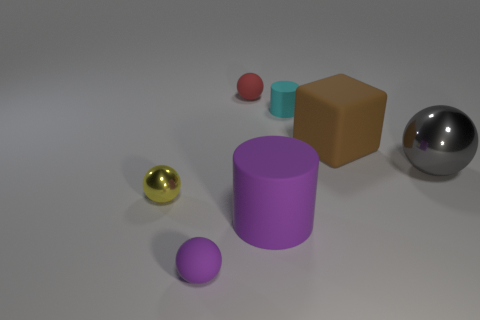There is a rubber object that is both on the left side of the big purple rubber cylinder and in front of the large brown cube; what size is it?
Your response must be concise. Small. There is a gray thing that is the same shape as the tiny purple thing; what size is it?
Ensure brevity in your answer.  Large. There is a thing that is the same color as the large cylinder; what is its material?
Ensure brevity in your answer.  Rubber. Is the color of the tiny rubber ball that is to the left of the red ball the same as the matte cylinder to the left of the small cylinder?
Your response must be concise. Yes. What is the color of the big thing that is the same shape as the tiny purple object?
Offer a terse response. Gray. What number of other objects are the same material as the large purple thing?
Offer a very short reply. 4. Is the color of the tiny metal object the same as the cylinder that is on the right side of the big purple cylinder?
Make the answer very short. No. What is the material of the small ball behind the big brown matte object?
Ensure brevity in your answer.  Rubber. Is there a large cube of the same color as the big ball?
Offer a very short reply. No. What is the color of the cylinder that is the same size as the yellow metal sphere?
Your answer should be compact. Cyan. 